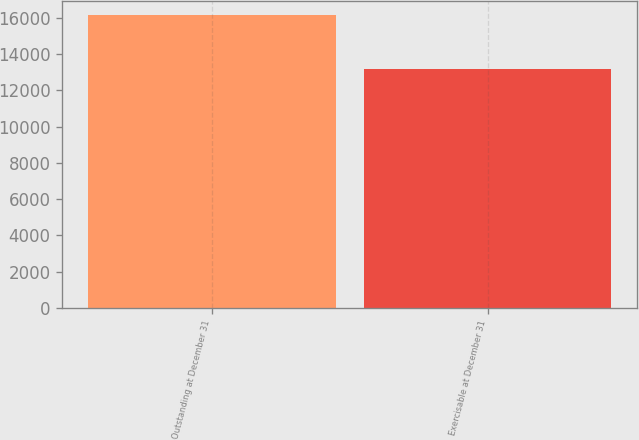Convert chart to OTSL. <chart><loc_0><loc_0><loc_500><loc_500><bar_chart><fcel>Outstanding at December 31<fcel>Exercisable at December 31<nl><fcel>16136<fcel>13204<nl></chart> 